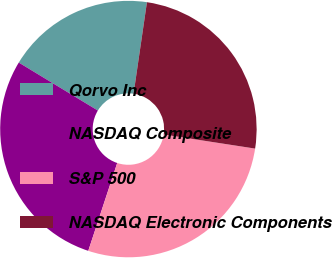<chart> <loc_0><loc_0><loc_500><loc_500><pie_chart><fcel>Qorvo Inc<fcel>NASDAQ Composite<fcel>S&P 500<fcel>NASDAQ Electronic Components<nl><fcel>18.63%<fcel>28.61%<fcel>27.63%<fcel>25.12%<nl></chart> 